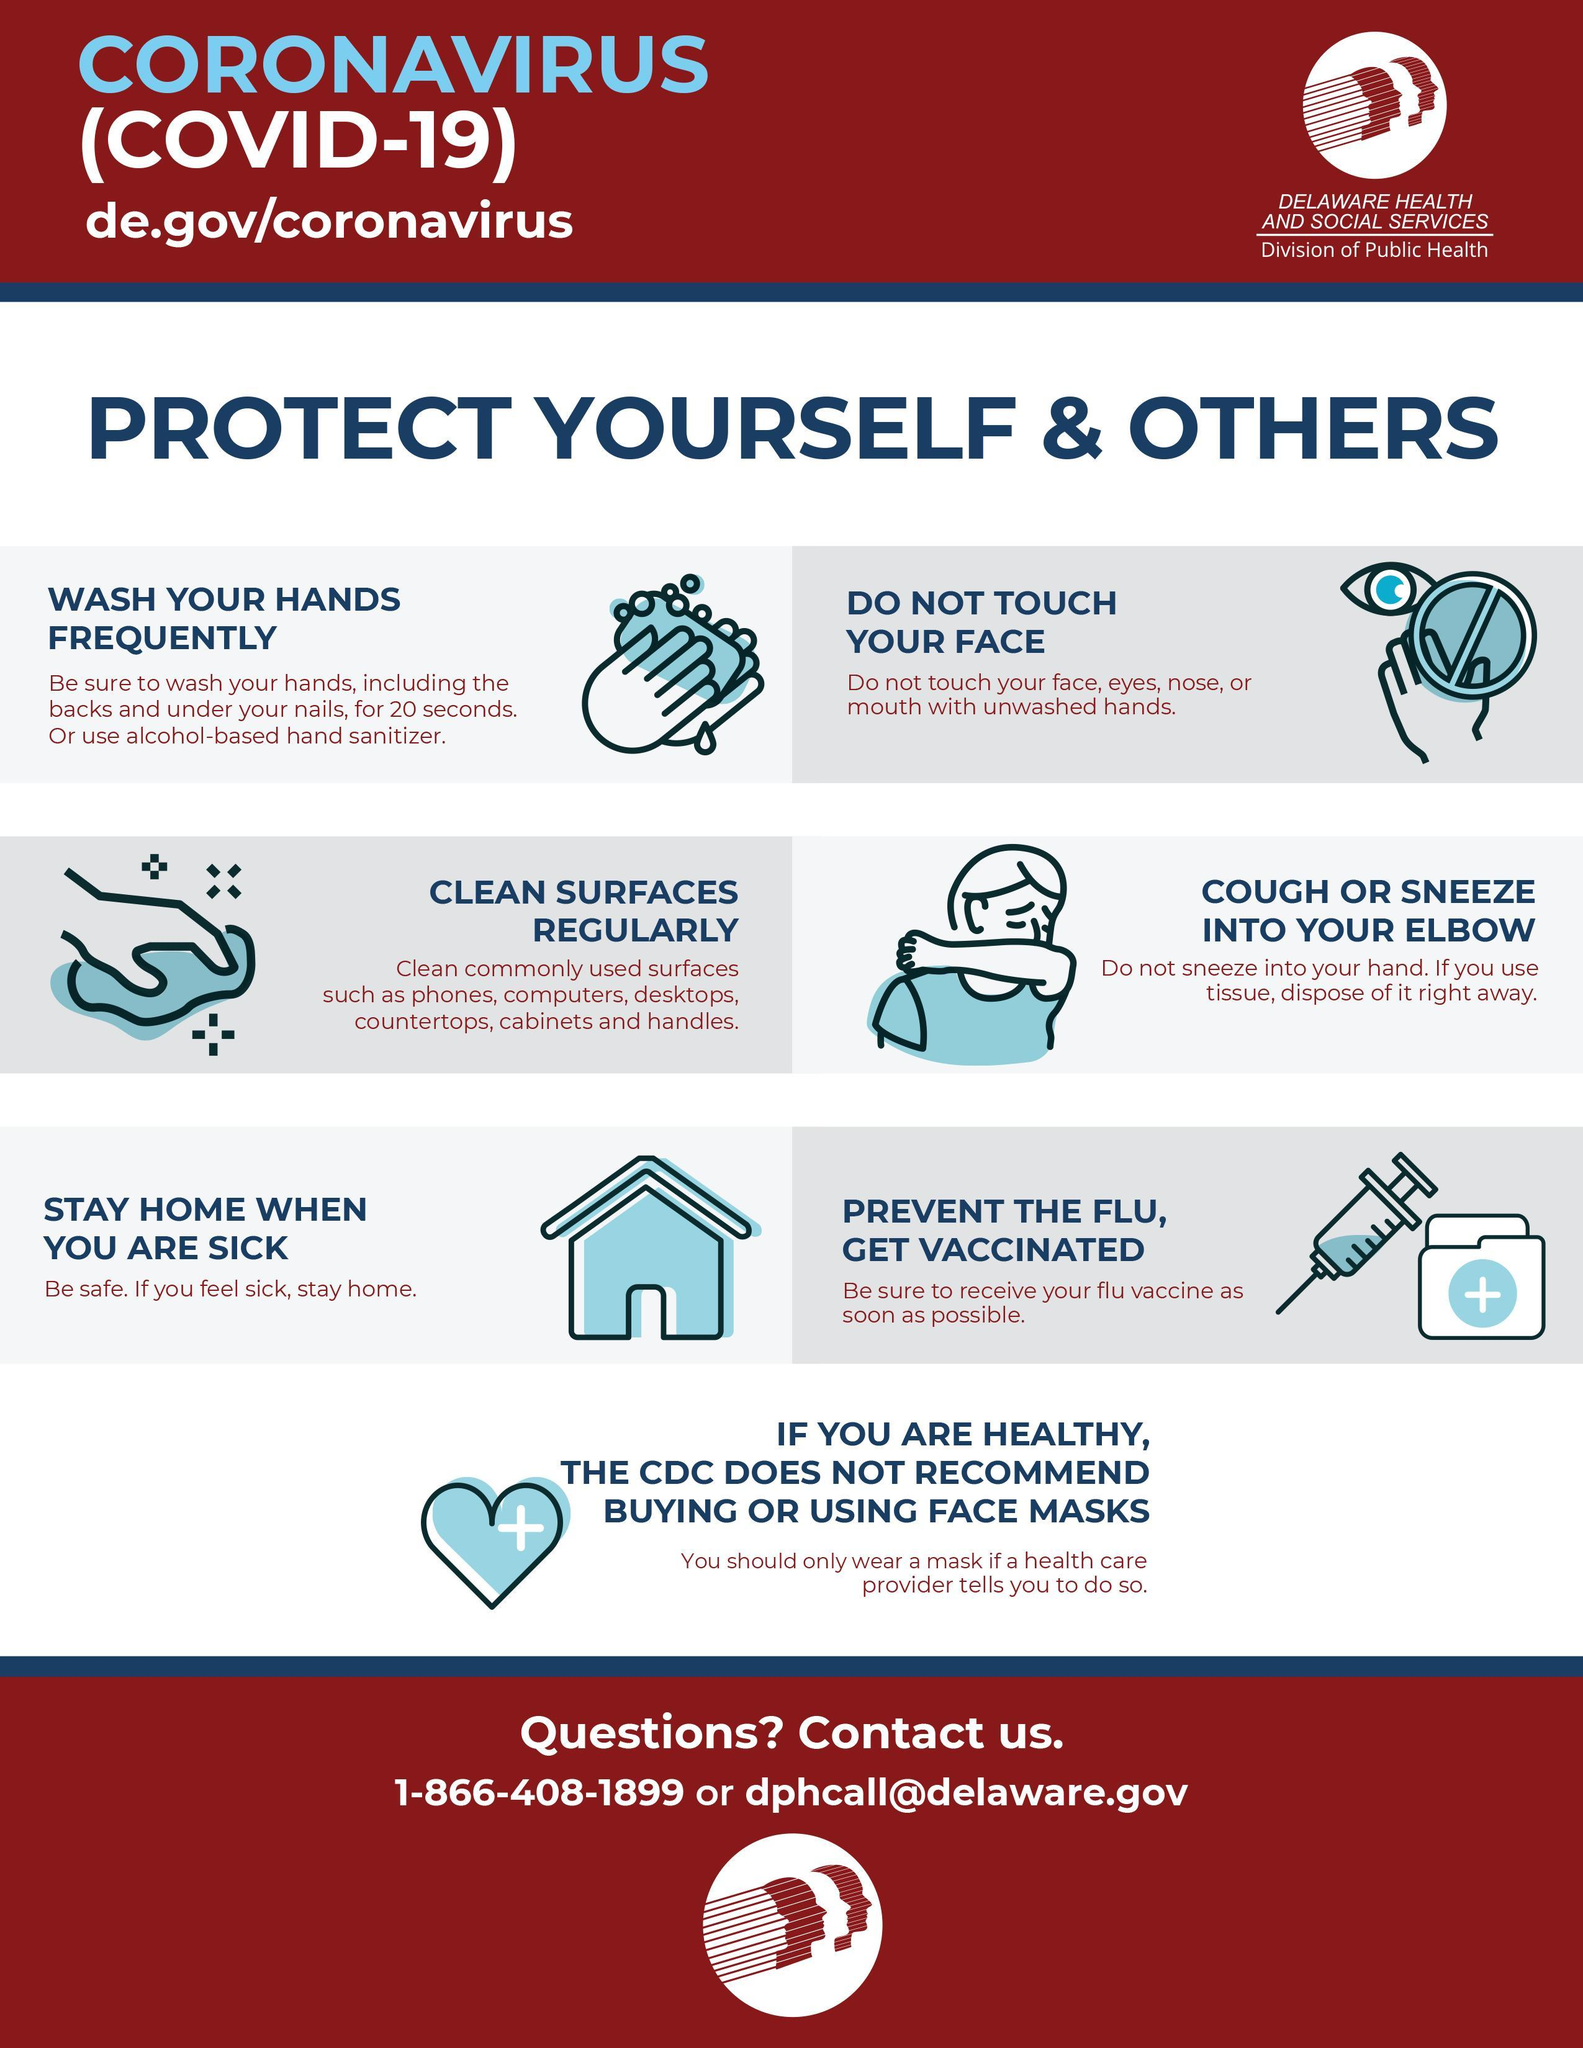What should be avoided while sneezing?
Answer the question with a short phrase. sneeze into your hand What's the step to be taken if someone is not well? stay home Which is the way to clean hands if not using water? use alcohol-based hand sanitizer 